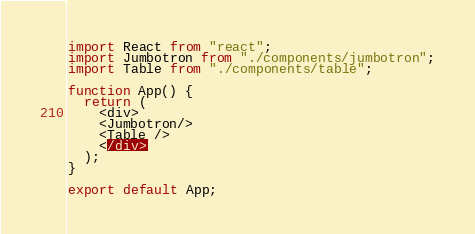<code> <loc_0><loc_0><loc_500><loc_500><_JavaScript_>import React from "react";
import Jumbotron from "./components/jumbotron";
import Table from "./components/table"; 

function App() {
  return (
    <div>
    <Jumbotron/>
    <Table />
    </div>
  );
}

export default App;</code> 